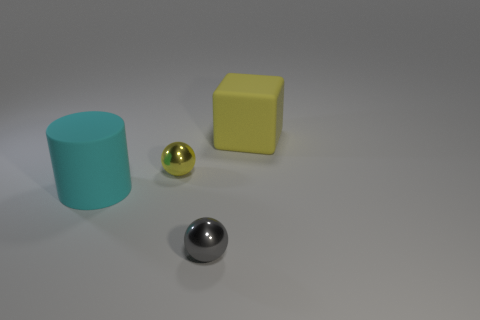Add 3 cyan rubber blocks. How many objects exist? 7 Subtract all purple cylinders. Subtract all cyan balls. How many cylinders are left? 1 Subtract all cylinders. How many objects are left? 3 Subtract 1 yellow blocks. How many objects are left? 3 Subtract all balls. Subtract all big matte cylinders. How many objects are left? 1 Add 1 cylinders. How many cylinders are left? 2 Add 1 big purple matte balls. How many big purple matte balls exist? 1 